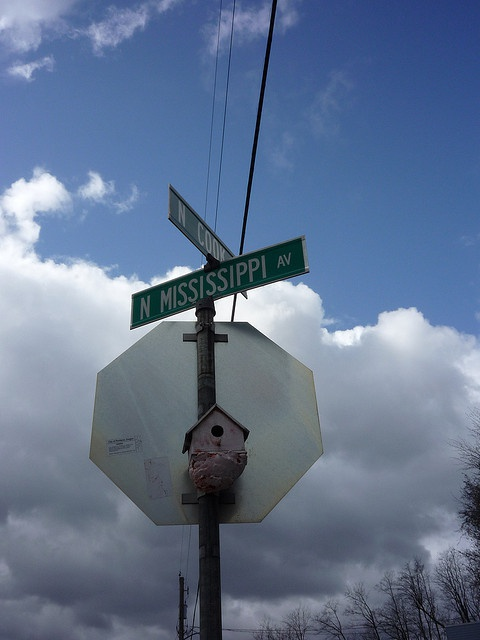Describe the objects in this image and their specific colors. I can see a stop sign in darkgray, gray, and black tones in this image. 